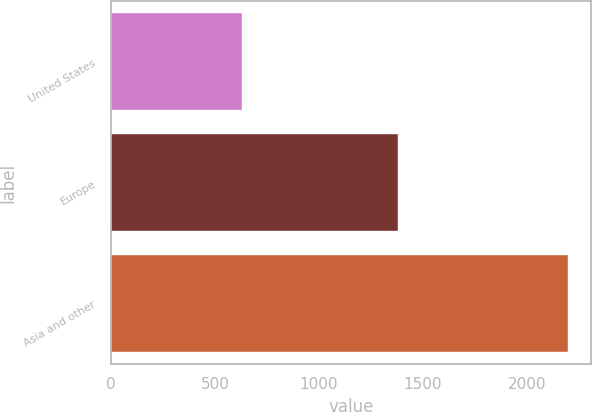Convert chart. <chart><loc_0><loc_0><loc_500><loc_500><bar_chart><fcel>United States<fcel>Europe<fcel>Asia and other<nl><fcel>628<fcel>1381<fcel>2200<nl></chart> 